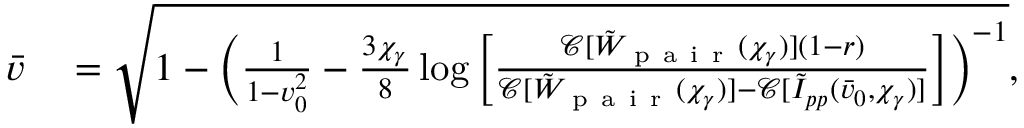Convert formula to latex. <formula><loc_0><loc_0><loc_500><loc_500>\begin{array} { r l } { \bar { v } } & = \sqrt { 1 - \left ( \frac { 1 } { 1 - v _ { 0 } ^ { 2 } } - \frac { 3 \chi _ { \gamma } } { 8 } \log { \left [ \frac { \mathcal { C } [ \tilde { W } _ { p a i r } ( \chi _ { \gamma } ) ] ( 1 - r ) } { \mathcal { C } [ \tilde { W } _ { p a i r } ( \chi _ { \gamma } ) ] - \mathcal { C } [ \tilde { I } _ { p p } ( \bar { v } _ { 0 } , \chi _ { \gamma } ) ] } \right ] } \right ) ^ { - 1 } } , } \end{array}</formula> 